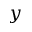<formula> <loc_0><loc_0><loc_500><loc_500>y</formula> 